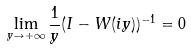Convert formula to latex. <formula><loc_0><loc_0><loc_500><loc_500>\lim _ { y \to + \infty } \frac { 1 } { y } ( I - W ( i y ) ) ^ { - 1 } = 0</formula> 